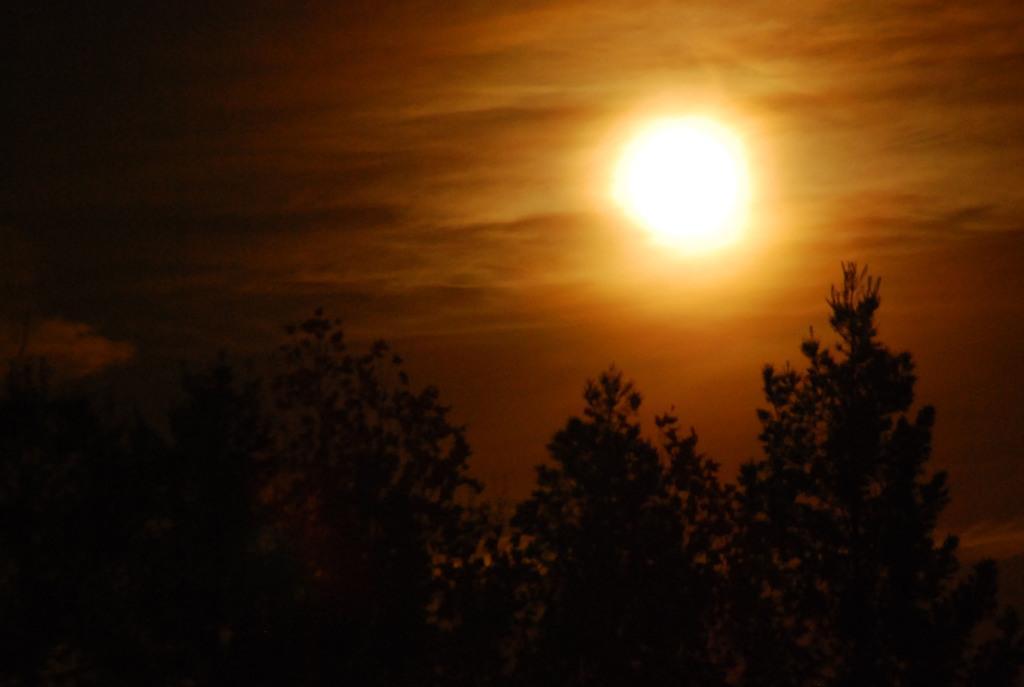How would you summarize this image in a sentence or two? In this image I can see many trees. In the background I can see the sun and the sky. 